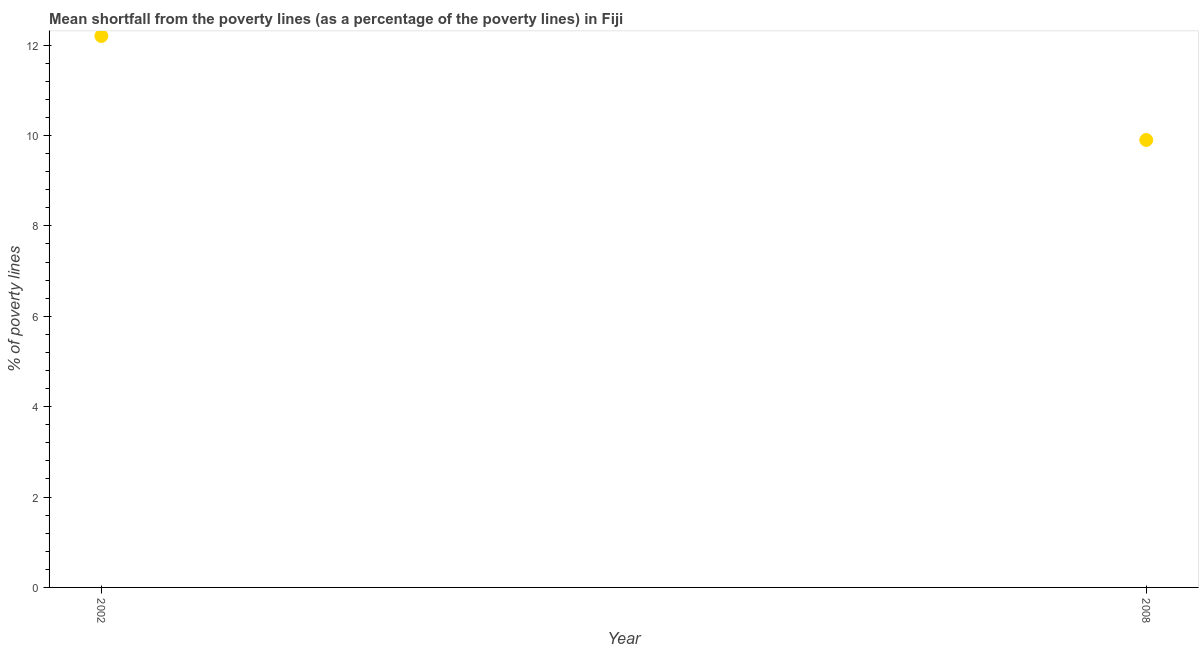In which year was the poverty gap at national poverty lines maximum?
Provide a succinct answer. 2002. In which year was the poverty gap at national poverty lines minimum?
Your response must be concise. 2008. What is the sum of the poverty gap at national poverty lines?
Keep it short and to the point. 22.1. What is the difference between the poverty gap at national poverty lines in 2002 and 2008?
Your answer should be very brief. 2.3. What is the average poverty gap at national poverty lines per year?
Make the answer very short. 11.05. What is the median poverty gap at national poverty lines?
Ensure brevity in your answer.  11.05. In how many years, is the poverty gap at national poverty lines greater than 10 %?
Offer a very short reply. 1. Do a majority of the years between 2008 and 2002 (inclusive) have poverty gap at national poverty lines greater than 4 %?
Offer a terse response. No. What is the ratio of the poverty gap at national poverty lines in 2002 to that in 2008?
Offer a very short reply. 1.23. Does the poverty gap at national poverty lines monotonically increase over the years?
Offer a very short reply. No. How many dotlines are there?
Give a very brief answer. 1. What is the difference between two consecutive major ticks on the Y-axis?
Ensure brevity in your answer.  2. What is the title of the graph?
Ensure brevity in your answer.  Mean shortfall from the poverty lines (as a percentage of the poverty lines) in Fiji. What is the label or title of the X-axis?
Your response must be concise. Year. What is the label or title of the Y-axis?
Your response must be concise. % of poverty lines. What is the ratio of the % of poverty lines in 2002 to that in 2008?
Give a very brief answer. 1.23. 